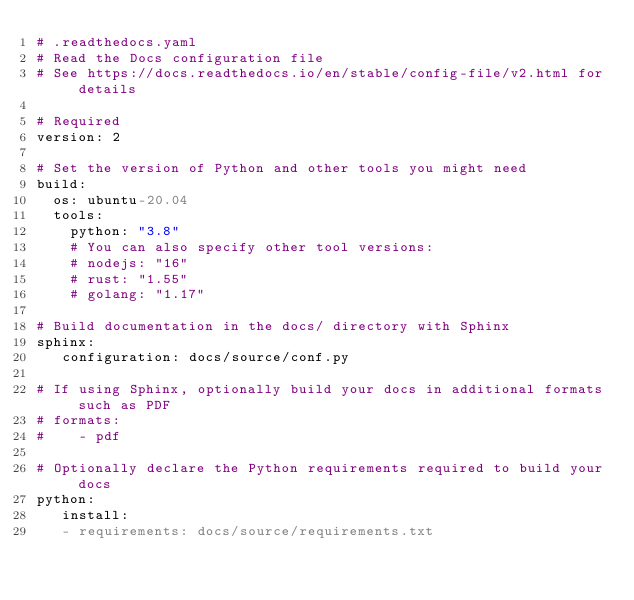Convert code to text. <code><loc_0><loc_0><loc_500><loc_500><_YAML_># .readthedocs.yaml
# Read the Docs configuration file
# See https://docs.readthedocs.io/en/stable/config-file/v2.html for details

# Required
version: 2

# Set the version of Python and other tools you might need
build:
  os: ubuntu-20.04
  tools:
    python: "3.8"
    # You can also specify other tool versions:
    # nodejs: "16"
    # rust: "1.55"
    # golang: "1.17"

# Build documentation in the docs/ directory with Sphinx
sphinx:
   configuration: docs/source/conf.py

# If using Sphinx, optionally build your docs in additional formats such as PDF
# formats:
#    - pdf

# Optionally declare the Python requirements required to build your docs
python:
   install:
   - requirements: docs/source/requirements.txt
</code> 